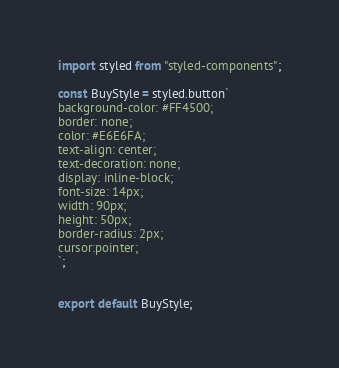Convert code to text. <code><loc_0><loc_0><loc_500><loc_500><_JavaScript_>import styled from "styled-components";

const BuyStyle = styled.button`
background-color: #FF4500;
border: none;
color: #E6E6FA;
text-align: center;
text-decoration: none;
display: inline-block;
font-size: 14px;
width: 90px;
height: 50px;
border-radius: 2px;
cursor:pointer;
`;


export default BuyStyle;
</code> 